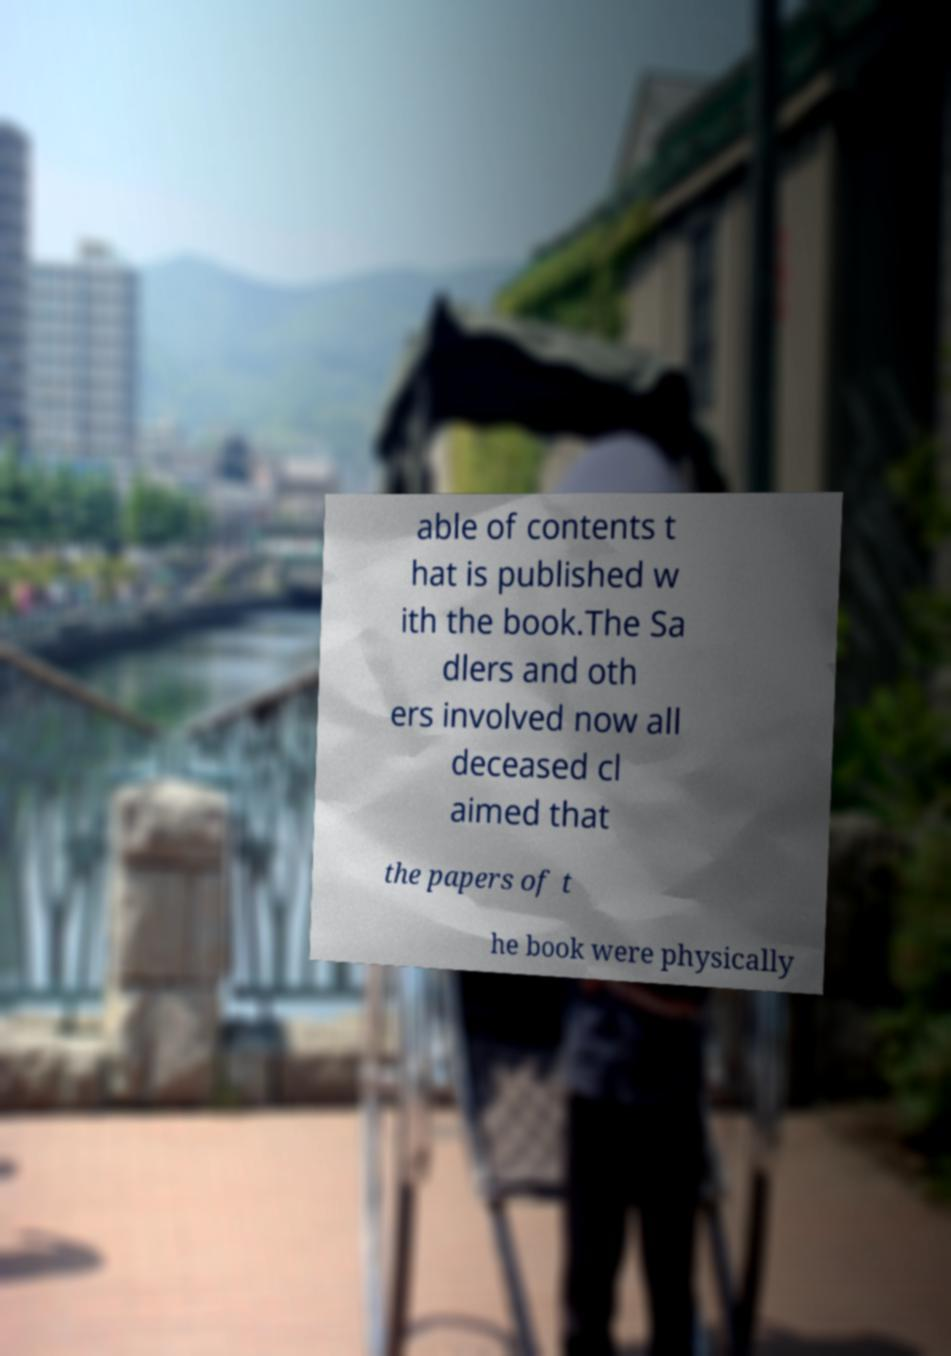Can you read and provide the text displayed in the image?This photo seems to have some interesting text. Can you extract and type it out for me? able of contents t hat is published w ith the book.The Sa dlers and oth ers involved now all deceased cl aimed that the papers of t he book were physically 